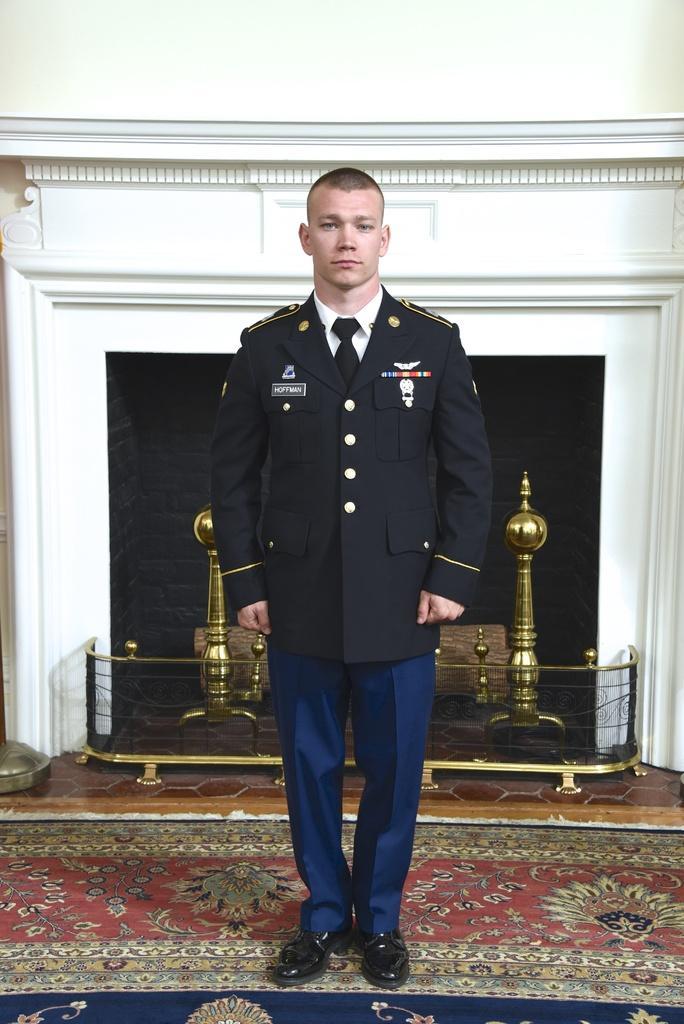Please provide a concise description of this image. In the foreground of this image, there is a man wearing black coat and blue pant standing on the floor carpet. In the background, it seems like a fireplace and on the top, there is the wall. 